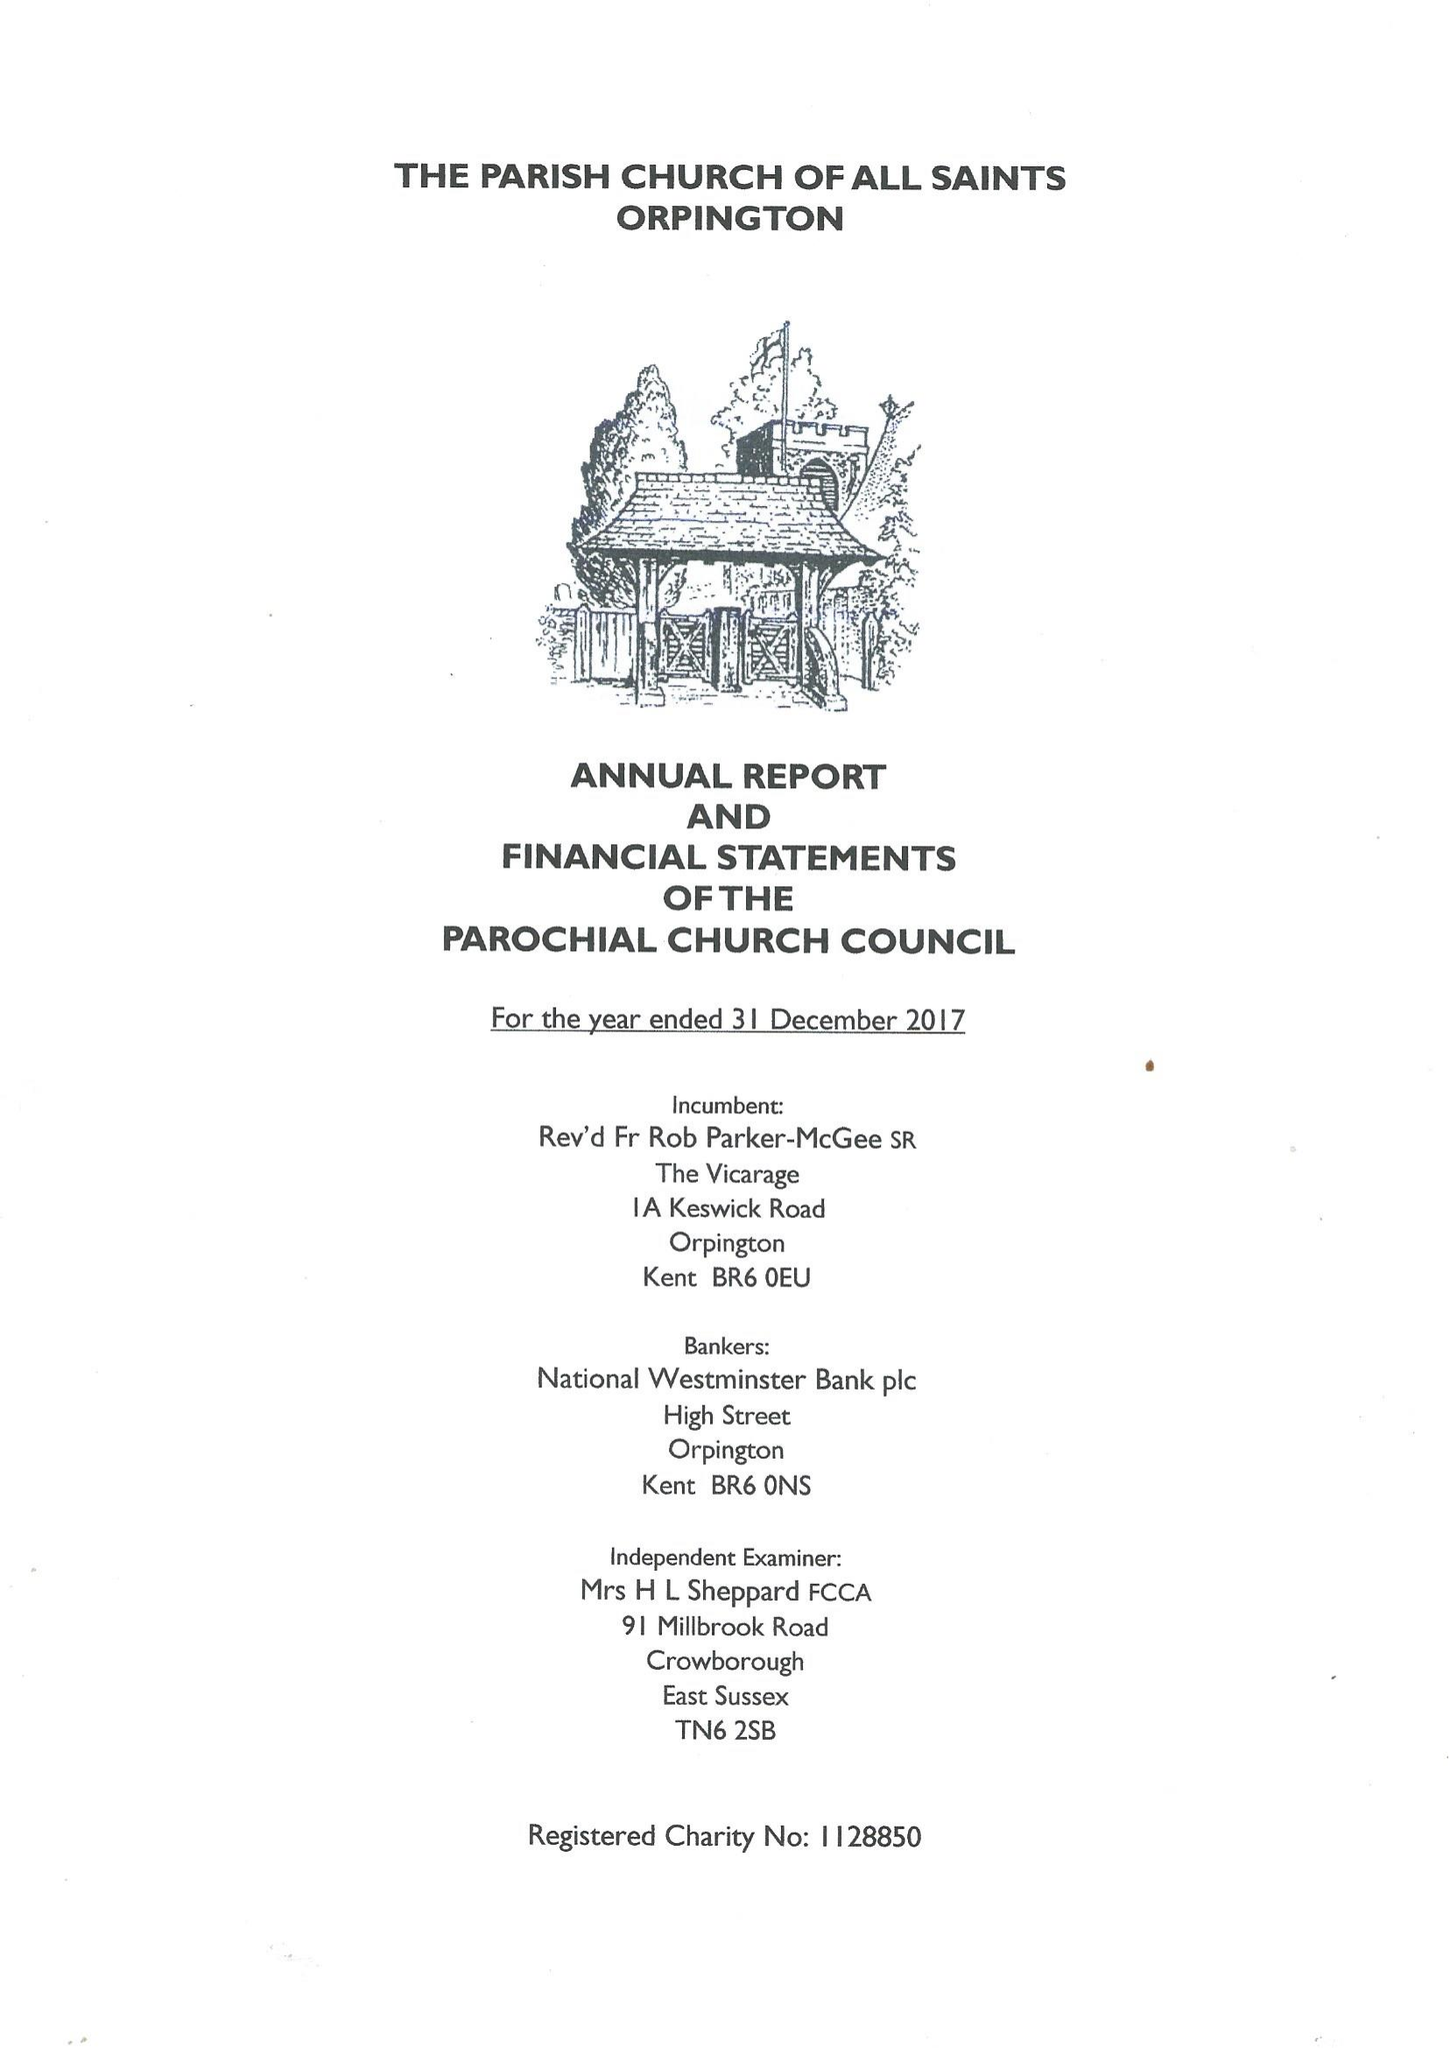What is the value for the report_date?
Answer the question using a single word or phrase. 2017-12-31 